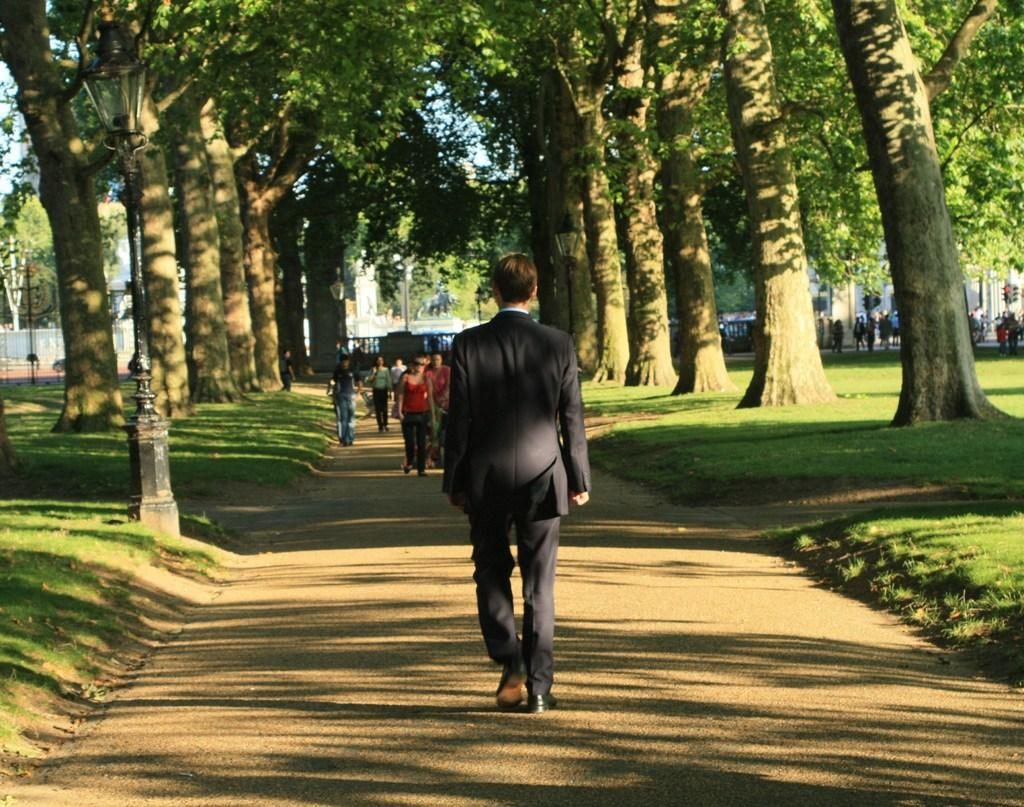What are the people in the image doing? The people in the image are walking in the sand. What type of vegetation can be seen in the image? There are green color trees in the image. What other natural elements are present in the image? There is grass in the image. What type of lunch is being served in the image? There is no lunch or any indication of food being served in the image. Where is the tub located in the image? There is no tub present in the image. 